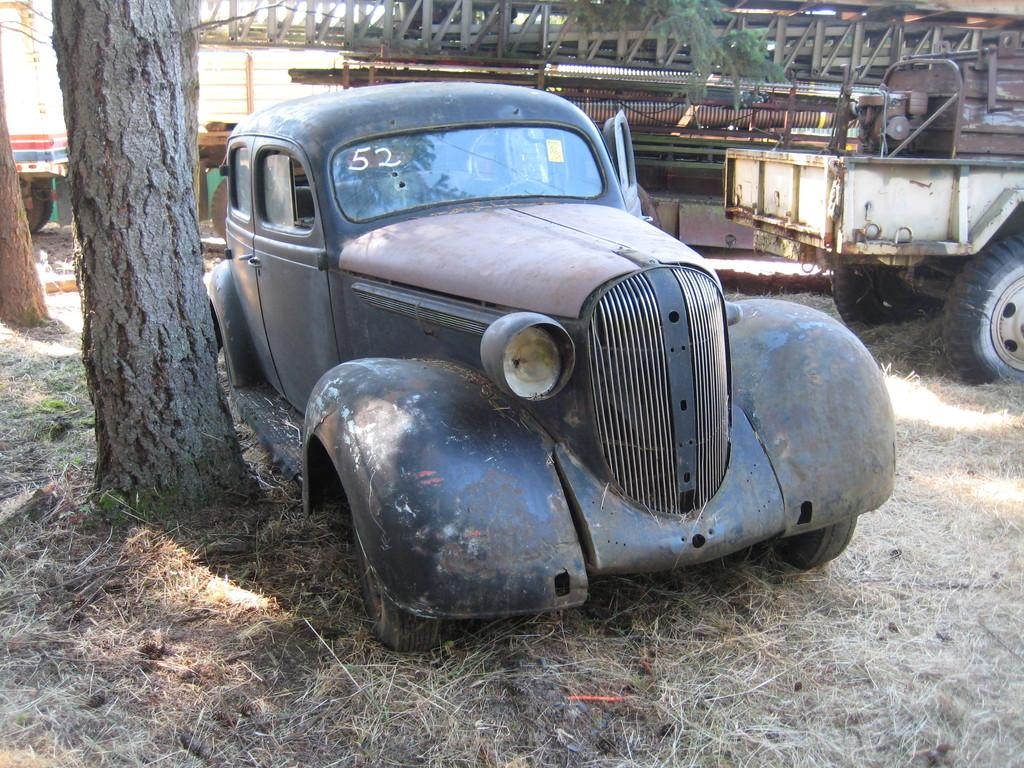What type of surface is visible in the image? There is ground visible in the image. What natural elements can be seen on the ground? There are two trees on the ground. What man-made objects are present on the ground? There are vehicles present on the ground. What type of glass is being offered by the son in the image? There is no son or glass present in the image. 